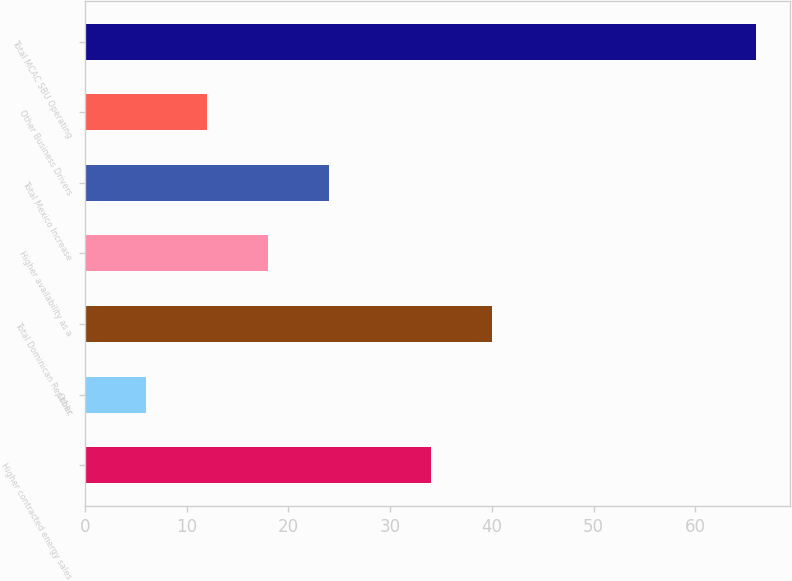Convert chart to OTSL. <chart><loc_0><loc_0><loc_500><loc_500><bar_chart><fcel>Higher contracted energy sales<fcel>Other<fcel>Total Dominican Republic<fcel>Higher availability as a<fcel>Total Mexico Increase<fcel>Other Business Drivers<fcel>Total MCAC SBU Operating<nl><fcel>34<fcel>6<fcel>40<fcel>18<fcel>24<fcel>12<fcel>66<nl></chart> 